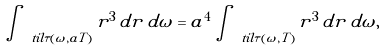<formula> <loc_0><loc_0><loc_500><loc_500>\int _ { \ t i l \tau ( \omega , a T ) } r ^ { 3 } \, d r \, d \omega = a ^ { 4 } \int _ { \ t i l \tau ( \omega , T ) } r ^ { 3 } \, d r \, d \omega ,</formula> 